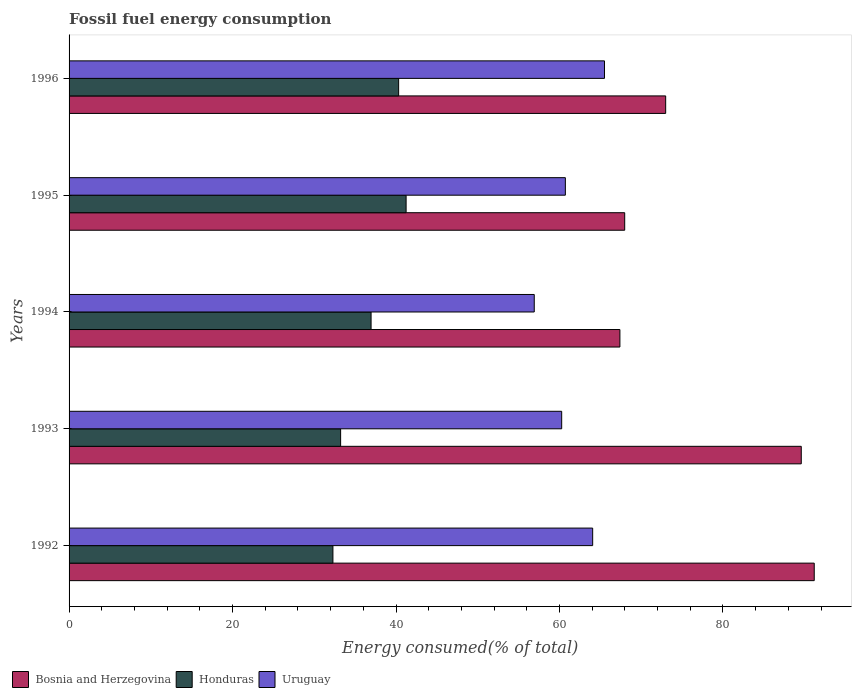Are the number of bars on each tick of the Y-axis equal?
Ensure brevity in your answer.  Yes. What is the label of the 5th group of bars from the top?
Provide a succinct answer. 1992. In how many cases, is the number of bars for a given year not equal to the number of legend labels?
Give a very brief answer. 0. What is the percentage of energy consumed in Bosnia and Herzegovina in 1993?
Provide a short and direct response. 89.58. Across all years, what is the maximum percentage of energy consumed in Bosnia and Herzegovina?
Your response must be concise. 91.17. Across all years, what is the minimum percentage of energy consumed in Honduras?
Provide a short and direct response. 32.28. In which year was the percentage of energy consumed in Honduras minimum?
Give a very brief answer. 1992. What is the total percentage of energy consumed in Uruguay in the graph?
Your answer should be very brief. 307.48. What is the difference between the percentage of energy consumed in Honduras in 1992 and that in 1995?
Keep it short and to the point. -8.95. What is the difference between the percentage of energy consumed in Honduras in 1994 and the percentage of energy consumed in Bosnia and Herzegovina in 1995?
Ensure brevity in your answer.  -31.03. What is the average percentage of energy consumed in Honduras per year?
Your answer should be very brief. 36.8. In the year 1996, what is the difference between the percentage of energy consumed in Honduras and percentage of energy consumed in Bosnia and Herzegovina?
Offer a very short reply. -32.67. In how many years, is the percentage of energy consumed in Honduras greater than 40 %?
Give a very brief answer. 2. What is the ratio of the percentage of energy consumed in Bosnia and Herzegovina in 1995 to that in 1996?
Offer a terse response. 0.93. What is the difference between the highest and the second highest percentage of energy consumed in Honduras?
Provide a succinct answer. 0.91. What is the difference between the highest and the lowest percentage of energy consumed in Honduras?
Give a very brief answer. 8.95. In how many years, is the percentage of energy consumed in Bosnia and Herzegovina greater than the average percentage of energy consumed in Bosnia and Herzegovina taken over all years?
Offer a terse response. 2. Is the sum of the percentage of energy consumed in Uruguay in 1992 and 1996 greater than the maximum percentage of energy consumed in Honduras across all years?
Your answer should be compact. Yes. What does the 3rd bar from the top in 1994 represents?
Provide a short and direct response. Bosnia and Herzegovina. What does the 3rd bar from the bottom in 1992 represents?
Your response must be concise. Uruguay. Are all the bars in the graph horizontal?
Offer a very short reply. Yes. Are the values on the major ticks of X-axis written in scientific E-notation?
Ensure brevity in your answer.  No. Does the graph contain any zero values?
Your response must be concise. No. Does the graph contain grids?
Provide a succinct answer. No. How many legend labels are there?
Give a very brief answer. 3. What is the title of the graph?
Offer a terse response. Fossil fuel energy consumption. Does "New Zealand" appear as one of the legend labels in the graph?
Keep it short and to the point. No. What is the label or title of the X-axis?
Your response must be concise. Energy consumed(% of total). What is the label or title of the Y-axis?
Give a very brief answer. Years. What is the Energy consumed(% of total) in Bosnia and Herzegovina in 1992?
Make the answer very short. 91.17. What is the Energy consumed(% of total) of Honduras in 1992?
Give a very brief answer. 32.28. What is the Energy consumed(% of total) of Uruguay in 1992?
Your response must be concise. 64.06. What is the Energy consumed(% of total) of Bosnia and Herzegovina in 1993?
Make the answer very short. 89.58. What is the Energy consumed(% of total) in Honduras in 1993?
Your response must be concise. 33.22. What is the Energy consumed(% of total) in Uruguay in 1993?
Your answer should be very brief. 60.27. What is the Energy consumed(% of total) in Bosnia and Herzegovina in 1994?
Your response must be concise. 67.39. What is the Energy consumed(% of total) in Honduras in 1994?
Your response must be concise. 36.95. What is the Energy consumed(% of total) in Uruguay in 1994?
Give a very brief answer. 56.92. What is the Energy consumed(% of total) of Bosnia and Herzegovina in 1995?
Your response must be concise. 67.98. What is the Energy consumed(% of total) in Honduras in 1995?
Ensure brevity in your answer.  41.24. What is the Energy consumed(% of total) in Uruguay in 1995?
Provide a succinct answer. 60.72. What is the Energy consumed(% of total) in Bosnia and Herzegovina in 1996?
Offer a terse response. 72.99. What is the Energy consumed(% of total) in Honduras in 1996?
Your answer should be compact. 40.32. What is the Energy consumed(% of total) in Uruguay in 1996?
Your response must be concise. 65.51. Across all years, what is the maximum Energy consumed(% of total) of Bosnia and Herzegovina?
Provide a short and direct response. 91.17. Across all years, what is the maximum Energy consumed(% of total) in Honduras?
Ensure brevity in your answer.  41.24. Across all years, what is the maximum Energy consumed(% of total) in Uruguay?
Offer a terse response. 65.51. Across all years, what is the minimum Energy consumed(% of total) in Bosnia and Herzegovina?
Offer a terse response. 67.39. Across all years, what is the minimum Energy consumed(% of total) of Honduras?
Your answer should be very brief. 32.28. Across all years, what is the minimum Energy consumed(% of total) in Uruguay?
Your answer should be compact. 56.92. What is the total Energy consumed(% of total) in Bosnia and Herzegovina in the graph?
Make the answer very short. 389.13. What is the total Energy consumed(% of total) of Honduras in the graph?
Your answer should be compact. 184.02. What is the total Energy consumed(% of total) of Uruguay in the graph?
Provide a succinct answer. 307.49. What is the difference between the Energy consumed(% of total) of Bosnia and Herzegovina in 1992 and that in 1993?
Your response must be concise. 1.59. What is the difference between the Energy consumed(% of total) in Honduras in 1992 and that in 1993?
Make the answer very short. -0.94. What is the difference between the Energy consumed(% of total) of Uruguay in 1992 and that in 1993?
Provide a succinct answer. 3.79. What is the difference between the Energy consumed(% of total) in Bosnia and Herzegovina in 1992 and that in 1994?
Your answer should be compact. 23.78. What is the difference between the Energy consumed(% of total) in Honduras in 1992 and that in 1994?
Provide a short and direct response. -4.67. What is the difference between the Energy consumed(% of total) in Uruguay in 1992 and that in 1994?
Your response must be concise. 7.15. What is the difference between the Energy consumed(% of total) in Bosnia and Herzegovina in 1992 and that in 1995?
Provide a short and direct response. 23.19. What is the difference between the Energy consumed(% of total) of Honduras in 1992 and that in 1995?
Your answer should be very brief. -8.95. What is the difference between the Energy consumed(% of total) of Uruguay in 1992 and that in 1995?
Offer a very short reply. 3.34. What is the difference between the Energy consumed(% of total) in Bosnia and Herzegovina in 1992 and that in 1996?
Keep it short and to the point. 18.18. What is the difference between the Energy consumed(% of total) of Honduras in 1992 and that in 1996?
Offer a terse response. -8.04. What is the difference between the Energy consumed(% of total) of Uruguay in 1992 and that in 1996?
Offer a very short reply. -1.45. What is the difference between the Energy consumed(% of total) in Bosnia and Herzegovina in 1993 and that in 1994?
Your answer should be very brief. 22.19. What is the difference between the Energy consumed(% of total) in Honduras in 1993 and that in 1994?
Ensure brevity in your answer.  -3.73. What is the difference between the Energy consumed(% of total) in Uruguay in 1993 and that in 1994?
Your answer should be compact. 3.36. What is the difference between the Energy consumed(% of total) of Bosnia and Herzegovina in 1993 and that in 1995?
Provide a succinct answer. 21.6. What is the difference between the Energy consumed(% of total) of Honduras in 1993 and that in 1995?
Keep it short and to the point. -8.01. What is the difference between the Energy consumed(% of total) of Uruguay in 1993 and that in 1995?
Your answer should be compact. -0.45. What is the difference between the Energy consumed(% of total) of Bosnia and Herzegovina in 1993 and that in 1996?
Provide a short and direct response. 16.59. What is the difference between the Energy consumed(% of total) in Honduras in 1993 and that in 1996?
Your answer should be compact. -7.1. What is the difference between the Energy consumed(% of total) of Uruguay in 1993 and that in 1996?
Your answer should be very brief. -5.24. What is the difference between the Energy consumed(% of total) in Bosnia and Herzegovina in 1994 and that in 1995?
Provide a short and direct response. -0.59. What is the difference between the Energy consumed(% of total) of Honduras in 1994 and that in 1995?
Ensure brevity in your answer.  -4.28. What is the difference between the Energy consumed(% of total) of Uruguay in 1994 and that in 1995?
Give a very brief answer. -3.81. What is the difference between the Energy consumed(% of total) of Bosnia and Herzegovina in 1994 and that in 1996?
Offer a terse response. -5.6. What is the difference between the Energy consumed(% of total) in Honduras in 1994 and that in 1996?
Offer a very short reply. -3.37. What is the difference between the Energy consumed(% of total) of Uruguay in 1994 and that in 1996?
Offer a very short reply. -8.59. What is the difference between the Energy consumed(% of total) in Bosnia and Herzegovina in 1995 and that in 1996?
Provide a short and direct response. -5.01. What is the difference between the Energy consumed(% of total) in Honduras in 1995 and that in 1996?
Make the answer very short. 0.91. What is the difference between the Energy consumed(% of total) in Uruguay in 1995 and that in 1996?
Your answer should be compact. -4.79. What is the difference between the Energy consumed(% of total) of Bosnia and Herzegovina in 1992 and the Energy consumed(% of total) of Honduras in 1993?
Keep it short and to the point. 57.95. What is the difference between the Energy consumed(% of total) of Bosnia and Herzegovina in 1992 and the Energy consumed(% of total) of Uruguay in 1993?
Provide a short and direct response. 30.9. What is the difference between the Energy consumed(% of total) in Honduras in 1992 and the Energy consumed(% of total) in Uruguay in 1993?
Offer a terse response. -27.99. What is the difference between the Energy consumed(% of total) of Bosnia and Herzegovina in 1992 and the Energy consumed(% of total) of Honduras in 1994?
Your response must be concise. 54.22. What is the difference between the Energy consumed(% of total) of Bosnia and Herzegovina in 1992 and the Energy consumed(% of total) of Uruguay in 1994?
Your response must be concise. 34.26. What is the difference between the Energy consumed(% of total) of Honduras in 1992 and the Energy consumed(% of total) of Uruguay in 1994?
Your response must be concise. -24.63. What is the difference between the Energy consumed(% of total) in Bosnia and Herzegovina in 1992 and the Energy consumed(% of total) in Honduras in 1995?
Keep it short and to the point. 49.94. What is the difference between the Energy consumed(% of total) of Bosnia and Herzegovina in 1992 and the Energy consumed(% of total) of Uruguay in 1995?
Provide a succinct answer. 30.45. What is the difference between the Energy consumed(% of total) in Honduras in 1992 and the Energy consumed(% of total) in Uruguay in 1995?
Provide a succinct answer. -28.44. What is the difference between the Energy consumed(% of total) in Bosnia and Herzegovina in 1992 and the Energy consumed(% of total) in Honduras in 1996?
Provide a short and direct response. 50.85. What is the difference between the Energy consumed(% of total) of Bosnia and Herzegovina in 1992 and the Energy consumed(% of total) of Uruguay in 1996?
Provide a succinct answer. 25.66. What is the difference between the Energy consumed(% of total) in Honduras in 1992 and the Energy consumed(% of total) in Uruguay in 1996?
Your answer should be very brief. -33.23. What is the difference between the Energy consumed(% of total) of Bosnia and Herzegovina in 1993 and the Energy consumed(% of total) of Honduras in 1994?
Offer a terse response. 52.63. What is the difference between the Energy consumed(% of total) in Bosnia and Herzegovina in 1993 and the Energy consumed(% of total) in Uruguay in 1994?
Your answer should be compact. 32.67. What is the difference between the Energy consumed(% of total) in Honduras in 1993 and the Energy consumed(% of total) in Uruguay in 1994?
Keep it short and to the point. -23.69. What is the difference between the Energy consumed(% of total) in Bosnia and Herzegovina in 1993 and the Energy consumed(% of total) in Honduras in 1995?
Keep it short and to the point. 48.35. What is the difference between the Energy consumed(% of total) in Bosnia and Herzegovina in 1993 and the Energy consumed(% of total) in Uruguay in 1995?
Make the answer very short. 28.86. What is the difference between the Energy consumed(% of total) of Honduras in 1993 and the Energy consumed(% of total) of Uruguay in 1995?
Ensure brevity in your answer.  -27.5. What is the difference between the Energy consumed(% of total) of Bosnia and Herzegovina in 1993 and the Energy consumed(% of total) of Honduras in 1996?
Give a very brief answer. 49.26. What is the difference between the Energy consumed(% of total) in Bosnia and Herzegovina in 1993 and the Energy consumed(% of total) in Uruguay in 1996?
Make the answer very short. 24.08. What is the difference between the Energy consumed(% of total) of Honduras in 1993 and the Energy consumed(% of total) of Uruguay in 1996?
Offer a terse response. -32.29. What is the difference between the Energy consumed(% of total) of Bosnia and Herzegovina in 1994 and the Energy consumed(% of total) of Honduras in 1995?
Your answer should be compact. 26.16. What is the difference between the Energy consumed(% of total) of Bosnia and Herzegovina in 1994 and the Energy consumed(% of total) of Uruguay in 1995?
Your response must be concise. 6.67. What is the difference between the Energy consumed(% of total) of Honduras in 1994 and the Energy consumed(% of total) of Uruguay in 1995?
Ensure brevity in your answer.  -23.77. What is the difference between the Energy consumed(% of total) in Bosnia and Herzegovina in 1994 and the Energy consumed(% of total) in Honduras in 1996?
Your answer should be very brief. 27.07. What is the difference between the Energy consumed(% of total) of Bosnia and Herzegovina in 1994 and the Energy consumed(% of total) of Uruguay in 1996?
Make the answer very short. 1.89. What is the difference between the Energy consumed(% of total) in Honduras in 1994 and the Energy consumed(% of total) in Uruguay in 1996?
Ensure brevity in your answer.  -28.56. What is the difference between the Energy consumed(% of total) of Bosnia and Herzegovina in 1995 and the Energy consumed(% of total) of Honduras in 1996?
Keep it short and to the point. 27.66. What is the difference between the Energy consumed(% of total) of Bosnia and Herzegovina in 1995 and the Energy consumed(% of total) of Uruguay in 1996?
Give a very brief answer. 2.47. What is the difference between the Energy consumed(% of total) of Honduras in 1995 and the Energy consumed(% of total) of Uruguay in 1996?
Provide a succinct answer. -24.27. What is the average Energy consumed(% of total) of Bosnia and Herzegovina per year?
Provide a succinct answer. 77.83. What is the average Energy consumed(% of total) of Honduras per year?
Offer a terse response. 36.8. What is the average Energy consumed(% of total) in Uruguay per year?
Your answer should be very brief. 61.5. In the year 1992, what is the difference between the Energy consumed(% of total) of Bosnia and Herzegovina and Energy consumed(% of total) of Honduras?
Offer a terse response. 58.89. In the year 1992, what is the difference between the Energy consumed(% of total) of Bosnia and Herzegovina and Energy consumed(% of total) of Uruguay?
Keep it short and to the point. 27.11. In the year 1992, what is the difference between the Energy consumed(% of total) in Honduras and Energy consumed(% of total) in Uruguay?
Give a very brief answer. -31.78. In the year 1993, what is the difference between the Energy consumed(% of total) of Bosnia and Herzegovina and Energy consumed(% of total) of Honduras?
Ensure brevity in your answer.  56.36. In the year 1993, what is the difference between the Energy consumed(% of total) in Bosnia and Herzegovina and Energy consumed(% of total) in Uruguay?
Make the answer very short. 29.31. In the year 1993, what is the difference between the Energy consumed(% of total) in Honduras and Energy consumed(% of total) in Uruguay?
Make the answer very short. -27.05. In the year 1994, what is the difference between the Energy consumed(% of total) in Bosnia and Herzegovina and Energy consumed(% of total) in Honduras?
Your response must be concise. 30.44. In the year 1994, what is the difference between the Energy consumed(% of total) in Bosnia and Herzegovina and Energy consumed(% of total) in Uruguay?
Provide a succinct answer. 10.48. In the year 1994, what is the difference between the Energy consumed(% of total) in Honduras and Energy consumed(% of total) in Uruguay?
Offer a very short reply. -19.96. In the year 1995, what is the difference between the Energy consumed(% of total) of Bosnia and Herzegovina and Energy consumed(% of total) of Honduras?
Offer a very short reply. 26.75. In the year 1995, what is the difference between the Energy consumed(% of total) in Bosnia and Herzegovina and Energy consumed(% of total) in Uruguay?
Your response must be concise. 7.26. In the year 1995, what is the difference between the Energy consumed(% of total) in Honduras and Energy consumed(% of total) in Uruguay?
Offer a very short reply. -19.49. In the year 1996, what is the difference between the Energy consumed(% of total) of Bosnia and Herzegovina and Energy consumed(% of total) of Honduras?
Keep it short and to the point. 32.67. In the year 1996, what is the difference between the Energy consumed(% of total) of Bosnia and Herzegovina and Energy consumed(% of total) of Uruguay?
Give a very brief answer. 7.49. In the year 1996, what is the difference between the Energy consumed(% of total) in Honduras and Energy consumed(% of total) in Uruguay?
Your answer should be compact. -25.19. What is the ratio of the Energy consumed(% of total) in Bosnia and Herzegovina in 1992 to that in 1993?
Make the answer very short. 1.02. What is the ratio of the Energy consumed(% of total) of Honduras in 1992 to that in 1993?
Offer a very short reply. 0.97. What is the ratio of the Energy consumed(% of total) in Uruguay in 1992 to that in 1993?
Provide a succinct answer. 1.06. What is the ratio of the Energy consumed(% of total) of Bosnia and Herzegovina in 1992 to that in 1994?
Provide a short and direct response. 1.35. What is the ratio of the Energy consumed(% of total) in Honduras in 1992 to that in 1994?
Provide a short and direct response. 0.87. What is the ratio of the Energy consumed(% of total) of Uruguay in 1992 to that in 1994?
Offer a terse response. 1.13. What is the ratio of the Energy consumed(% of total) in Bosnia and Herzegovina in 1992 to that in 1995?
Offer a terse response. 1.34. What is the ratio of the Energy consumed(% of total) of Honduras in 1992 to that in 1995?
Ensure brevity in your answer.  0.78. What is the ratio of the Energy consumed(% of total) in Uruguay in 1992 to that in 1995?
Give a very brief answer. 1.05. What is the ratio of the Energy consumed(% of total) in Bosnia and Herzegovina in 1992 to that in 1996?
Provide a short and direct response. 1.25. What is the ratio of the Energy consumed(% of total) of Honduras in 1992 to that in 1996?
Your answer should be compact. 0.8. What is the ratio of the Energy consumed(% of total) in Uruguay in 1992 to that in 1996?
Offer a terse response. 0.98. What is the ratio of the Energy consumed(% of total) of Bosnia and Herzegovina in 1993 to that in 1994?
Your answer should be very brief. 1.33. What is the ratio of the Energy consumed(% of total) of Honduras in 1993 to that in 1994?
Keep it short and to the point. 0.9. What is the ratio of the Energy consumed(% of total) of Uruguay in 1993 to that in 1994?
Your answer should be very brief. 1.06. What is the ratio of the Energy consumed(% of total) of Bosnia and Herzegovina in 1993 to that in 1995?
Your answer should be very brief. 1.32. What is the ratio of the Energy consumed(% of total) in Honduras in 1993 to that in 1995?
Offer a very short reply. 0.81. What is the ratio of the Energy consumed(% of total) in Bosnia and Herzegovina in 1993 to that in 1996?
Provide a short and direct response. 1.23. What is the ratio of the Energy consumed(% of total) of Honduras in 1993 to that in 1996?
Your answer should be very brief. 0.82. What is the ratio of the Energy consumed(% of total) in Uruguay in 1993 to that in 1996?
Your answer should be very brief. 0.92. What is the ratio of the Energy consumed(% of total) of Bosnia and Herzegovina in 1994 to that in 1995?
Offer a terse response. 0.99. What is the ratio of the Energy consumed(% of total) of Honduras in 1994 to that in 1995?
Provide a succinct answer. 0.9. What is the ratio of the Energy consumed(% of total) of Uruguay in 1994 to that in 1995?
Your answer should be compact. 0.94. What is the ratio of the Energy consumed(% of total) of Bosnia and Herzegovina in 1994 to that in 1996?
Ensure brevity in your answer.  0.92. What is the ratio of the Energy consumed(% of total) of Honduras in 1994 to that in 1996?
Offer a terse response. 0.92. What is the ratio of the Energy consumed(% of total) of Uruguay in 1994 to that in 1996?
Provide a succinct answer. 0.87. What is the ratio of the Energy consumed(% of total) in Bosnia and Herzegovina in 1995 to that in 1996?
Offer a terse response. 0.93. What is the ratio of the Energy consumed(% of total) of Honduras in 1995 to that in 1996?
Provide a succinct answer. 1.02. What is the ratio of the Energy consumed(% of total) in Uruguay in 1995 to that in 1996?
Provide a succinct answer. 0.93. What is the difference between the highest and the second highest Energy consumed(% of total) of Bosnia and Herzegovina?
Offer a very short reply. 1.59. What is the difference between the highest and the second highest Energy consumed(% of total) in Honduras?
Your answer should be compact. 0.91. What is the difference between the highest and the second highest Energy consumed(% of total) of Uruguay?
Provide a succinct answer. 1.45. What is the difference between the highest and the lowest Energy consumed(% of total) in Bosnia and Herzegovina?
Your answer should be compact. 23.78. What is the difference between the highest and the lowest Energy consumed(% of total) of Honduras?
Provide a short and direct response. 8.95. What is the difference between the highest and the lowest Energy consumed(% of total) in Uruguay?
Offer a terse response. 8.59. 